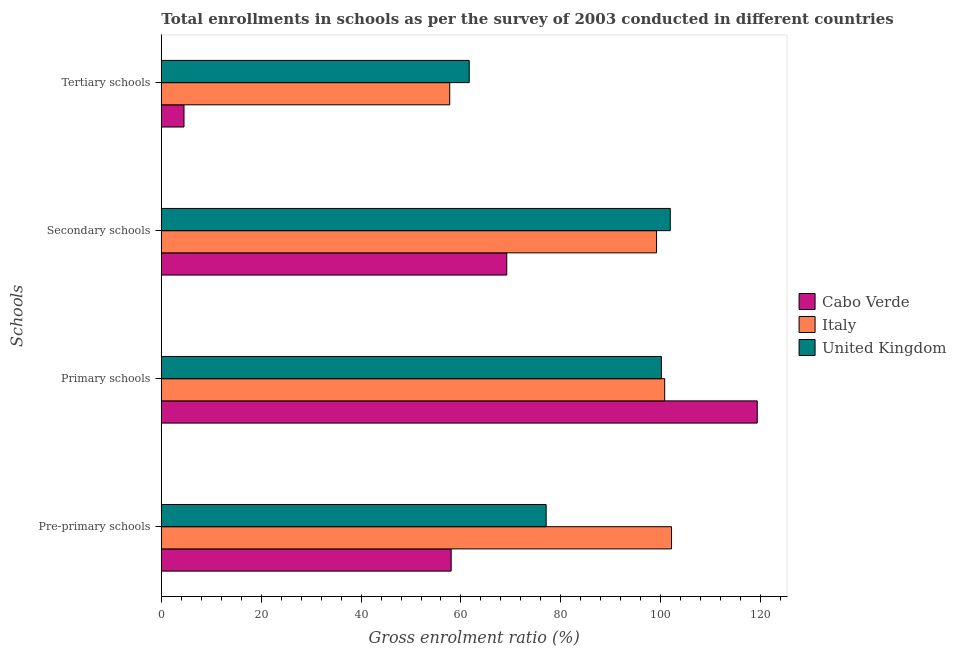Are the number of bars per tick equal to the number of legend labels?
Offer a terse response. Yes. Are the number of bars on each tick of the Y-axis equal?
Keep it short and to the point. Yes. How many bars are there on the 4th tick from the top?
Your answer should be very brief. 3. What is the label of the 2nd group of bars from the top?
Provide a succinct answer. Secondary schools. What is the gross enrolment ratio in tertiary schools in Italy?
Provide a succinct answer. 57.75. Across all countries, what is the maximum gross enrolment ratio in pre-primary schools?
Make the answer very short. 102.16. Across all countries, what is the minimum gross enrolment ratio in primary schools?
Give a very brief answer. 100.13. In which country was the gross enrolment ratio in tertiary schools minimum?
Offer a very short reply. Cabo Verde. What is the total gross enrolment ratio in pre-primary schools in the graph?
Provide a short and direct response. 237.26. What is the difference between the gross enrolment ratio in primary schools in United Kingdom and that in Cabo Verde?
Offer a very short reply. -19.2. What is the difference between the gross enrolment ratio in secondary schools in Cabo Verde and the gross enrolment ratio in tertiary schools in United Kingdom?
Your response must be concise. 7.51. What is the average gross enrolment ratio in primary schools per country?
Your response must be concise. 106.75. What is the difference between the gross enrolment ratio in tertiary schools and gross enrolment ratio in primary schools in Cabo Verde?
Provide a succinct answer. -114.79. What is the ratio of the gross enrolment ratio in primary schools in Cabo Verde to that in Italy?
Your response must be concise. 1.18. Is the gross enrolment ratio in tertiary schools in Cabo Verde less than that in United Kingdom?
Ensure brevity in your answer.  Yes. Is the difference between the gross enrolment ratio in primary schools in Italy and United Kingdom greater than the difference between the gross enrolment ratio in tertiary schools in Italy and United Kingdom?
Give a very brief answer. Yes. What is the difference between the highest and the second highest gross enrolment ratio in pre-primary schools?
Keep it short and to the point. 25.1. What is the difference between the highest and the lowest gross enrolment ratio in primary schools?
Your answer should be very brief. 19.2. In how many countries, is the gross enrolment ratio in tertiary schools greater than the average gross enrolment ratio in tertiary schools taken over all countries?
Offer a very short reply. 2. Is the sum of the gross enrolment ratio in secondary schools in Italy and United Kingdom greater than the maximum gross enrolment ratio in pre-primary schools across all countries?
Keep it short and to the point. Yes. What does the 1st bar from the bottom in Primary schools represents?
Ensure brevity in your answer.  Cabo Verde. Is it the case that in every country, the sum of the gross enrolment ratio in pre-primary schools and gross enrolment ratio in primary schools is greater than the gross enrolment ratio in secondary schools?
Keep it short and to the point. Yes. How many bars are there?
Provide a short and direct response. 12. Are all the bars in the graph horizontal?
Provide a short and direct response. Yes. How many countries are there in the graph?
Ensure brevity in your answer.  3. Does the graph contain grids?
Offer a terse response. No. Where does the legend appear in the graph?
Offer a very short reply. Center right. How many legend labels are there?
Offer a terse response. 3. How are the legend labels stacked?
Provide a short and direct response. Vertical. What is the title of the graph?
Give a very brief answer. Total enrollments in schools as per the survey of 2003 conducted in different countries. Does "Macedonia" appear as one of the legend labels in the graph?
Provide a succinct answer. No. What is the label or title of the Y-axis?
Ensure brevity in your answer.  Schools. What is the Gross enrolment ratio (%) in Cabo Verde in Pre-primary schools?
Your answer should be compact. 58.04. What is the Gross enrolment ratio (%) of Italy in Pre-primary schools?
Your response must be concise. 102.16. What is the Gross enrolment ratio (%) of United Kingdom in Pre-primary schools?
Give a very brief answer. 77.06. What is the Gross enrolment ratio (%) in Cabo Verde in Primary schools?
Keep it short and to the point. 119.33. What is the Gross enrolment ratio (%) in Italy in Primary schools?
Make the answer very short. 100.79. What is the Gross enrolment ratio (%) in United Kingdom in Primary schools?
Make the answer very short. 100.13. What is the Gross enrolment ratio (%) of Cabo Verde in Secondary schools?
Provide a succinct answer. 69.17. What is the Gross enrolment ratio (%) in Italy in Secondary schools?
Offer a very short reply. 99.16. What is the Gross enrolment ratio (%) in United Kingdom in Secondary schools?
Your response must be concise. 101.91. What is the Gross enrolment ratio (%) in Cabo Verde in Tertiary schools?
Keep it short and to the point. 4.54. What is the Gross enrolment ratio (%) in Italy in Tertiary schools?
Offer a very short reply. 57.75. What is the Gross enrolment ratio (%) in United Kingdom in Tertiary schools?
Your answer should be compact. 61.66. Across all Schools, what is the maximum Gross enrolment ratio (%) of Cabo Verde?
Make the answer very short. 119.33. Across all Schools, what is the maximum Gross enrolment ratio (%) of Italy?
Your answer should be compact. 102.16. Across all Schools, what is the maximum Gross enrolment ratio (%) of United Kingdom?
Make the answer very short. 101.91. Across all Schools, what is the minimum Gross enrolment ratio (%) in Cabo Verde?
Offer a terse response. 4.54. Across all Schools, what is the minimum Gross enrolment ratio (%) in Italy?
Make the answer very short. 57.75. Across all Schools, what is the minimum Gross enrolment ratio (%) in United Kingdom?
Offer a terse response. 61.66. What is the total Gross enrolment ratio (%) of Cabo Verde in the graph?
Your answer should be compact. 251.08. What is the total Gross enrolment ratio (%) of Italy in the graph?
Your answer should be compact. 359.87. What is the total Gross enrolment ratio (%) in United Kingdom in the graph?
Make the answer very short. 340.76. What is the difference between the Gross enrolment ratio (%) of Cabo Verde in Pre-primary schools and that in Primary schools?
Keep it short and to the point. -61.29. What is the difference between the Gross enrolment ratio (%) in Italy in Pre-primary schools and that in Primary schools?
Offer a terse response. 1.37. What is the difference between the Gross enrolment ratio (%) of United Kingdom in Pre-primary schools and that in Primary schools?
Your answer should be very brief. -23.07. What is the difference between the Gross enrolment ratio (%) in Cabo Verde in Pre-primary schools and that in Secondary schools?
Keep it short and to the point. -11.13. What is the difference between the Gross enrolment ratio (%) of Italy in Pre-primary schools and that in Secondary schools?
Make the answer very short. 3. What is the difference between the Gross enrolment ratio (%) in United Kingdom in Pre-primary schools and that in Secondary schools?
Keep it short and to the point. -24.85. What is the difference between the Gross enrolment ratio (%) in Cabo Verde in Pre-primary schools and that in Tertiary schools?
Ensure brevity in your answer.  53.5. What is the difference between the Gross enrolment ratio (%) of Italy in Pre-primary schools and that in Tertiary schools?
Offer a terse response. 44.41. What is the difference between the Gross enrolment ratio (%) of United Kingdom in Pre-primary schools and that in Tertiary schools?
Ensure brevity in your answer.  15.4. What is the difference between the Gross enrolment ratio (%) of Cabo Verde in Primary schools and that in Secondary schools?
Provide a succinct answer. 50.16. What is the difference between the Gross enrolment ratio (%) of Italy in Primary schools and that in Secondary schools?
Your response must be concise. 1.63. What is the difference between the Gross enrolment ratio (%) in United Kingdom in Primary schools and that in Secondary schools?
Ensure brevity in your answer.  -1.78. What is the difference between the Gross enrolment ratio (%) in Cabo Verde in Primary schools and that in Tertiary schools?
Provide a succinct answer. 114.79. What is the difference between the Gross enrolment ratio (%) in Italy in Primary schools and that in Tertiary schools?
Ensure brevity in your answer.  43.04. What is the difference between the Gross enrolment ratio (%) in United Kingdom in Primary schools and that in Tertiary schools?
Offer a terse response. 38.48. What is the difference between the Gross enrolment ratio (%) of Cabo Verde in Secondary schools and that in Tertiary schools?
Provide a succinct answer. 64.63. What is the difference between the Gross enrolment ratio (%) in Italy in Secondary schools and that in Tertiary schools?
Your answer should be very brief. 41.41. What is the difference between the Gross enrolment ratio (%) in United Kingdom in Secondary schools and that in Tertiary schools?
Provide a succinct answer. 40.25. What is the difference between the Gross enrolment ratio (%) in Cabo Verde in Pre-primary schools and the Gross enrolment ratio (%) in Italy in Primary schools?
Ensure brevity in your answer.  -42.75. What is the difference between the Gross enrolment ratio (%) of Cabo Verde in Pre-primary schools and the Gross enrolment ratio (%) of United Kingdom in Primary schools?
Provide a short and direct response. -42.09. What is the difference between the Gross enrolment ratio (%) of Italy in Pre-primary schools and the Gross enrolment ratio (%) of United Kingdom in Primary schools?
Make the answer very short. 2.03. What is the difference between the Gross enrolment ratio (%) of Cabo Verde in Pre-primary schools and the Gross enrolment ratio (%) of Italy in Secondary schools?
Keep it short and to the point. -41.13. What is the difference between the Gross enrolment ratio (%) in Cabo Verde in Pre-primary schools and the Gross enrolment ratio (%) in United Kingdom in Secondary schools?
Give a very brief answer. -43.87. What is the difference between the Gross enrolment ratio (%) of Italy in Pre-primary schools and the Gross enrolment ratio (%) of United Kingdom in Secondary schools?
Your answer should be compact. 0.25. What is the difference between the Gross enrolment ratio (%) of Cabo Verde in Pre-primary schools and the Gross enrolment ratio (%) of Italy in Tertiary schools?
Your response must be concise. 0.29. What is the difference between the Gross enrolment ratio (%) in Cabo Verde in Pre-primary schools and the Gross enrolment ratio (%) in United Kingdom in Tertiary schools?
Provide a short and direct response. -3.62. What is the difference between the Gross enrolment ratio (%) in Italy in Pre-primary schools and the Gross enrolment ratio (%) in United Kingdom in Tertiary schools?
Give a very brief answer. 40.51. What is the difference between the Gross enrolment ratio (%) in Cabo Verde in Primary schools and the Gross enrolment ratio (%) in Italy in Secondary schools?
Provide a succinct answer. 20.17. What is the difference between the Gross enrolment ratio (%) in Cabo Verde in Primary schools and the Gross enrolment ratio (%) in United Kingdom in Secondary schools?
Make the answer very short. 17.42. What is the difference between the Gross enrolment ratio (%) in Italy in Primary schools and the Gross enrolment ratio (%) in United Kingdom in Secondary schools?
Offer a very short reply. -1.12. What is the difference between the Gross enrolment ratio (%) in Cabo Verde in Primary schools and the Gross enrolment ratio (%) in Italy in Tertiary schools?
Offer a terse response. 61.58. What is the difference between the Gross enrolment ratio (%) of Cabo Verde in Primary schools and the Gross enrolment ratio (%) of United Kingdom in Tertiary schools?
Give a very brief answer. 57.67. What is the difference between the Gross enrolment ratio (%) of Italy in Primary schools and the Gross enrolment ratio (%) of United Kingdom in Tertiary schools?
Offer a very short reply. 39.14. What is the difference between the Gross enrolment ratio (%) of Cabo Verde in Secondary schools and the Gross enrolment ratio (%) of Italy in Tertiary schools?
Your answer should be very brief. 11.42. What is the difference between the Gross enrolment ratio (%) in Cabo Verde in Secondary schools and the Gross enrolment ratio (%) in United Kingdom in Tertiary schools?
Offer a terse response. 7.51. What is the difference between the Gross enrolment ratio (%) in Italy in Secondary schools and the Gross enrolment ratio (%) in United Kingdom in Tertiary schools?
Ensure brevity in your answer.  37.51. What is the average Gross enrolment ratio (%) of Cabo Verde per Schools?
Give a very brief answer. 62.77. What is the average Gross enrolment ratio (%) in Italy per Schools?
Your answer should be very brief. 89.97. What is the average Gross enrolment ratio (%) in United Kingdom per Schools?
Provide a succinct answer. 85.19. What is the difference between the Gross enrolment ratio (%) of Cabo Verde and Gross enrolment ratio (%) of Italy in Pre-primary schools?
Provide a succinct answer. -44.12. What is the difference between the Gross enrolment ratio (%) of Cabo Verde and Gross enrolment ratio (%) of United Kingdom in Pre-primary schools?
Provide a succinct answer. -19.02. What is the difference between the Gross enrolment ratio (%) of Italy and Gross enrolment ratio (%) of United Kingdom in Pre-primary schools?
Provide a succinct answer. 25.1. What is the difference between the Gross enrolment ratio (%) in Cabo Verde and Gross enrolment ratio (%) in Italy in Primary schools?
Keep it short and to the point. 18.54. What is the difference between the Gross enrolment ratio (%) of Cabo Verde and Gross enrolment ratio (%) of United Kingdom in Primary schools?
Keep it short and to the point. 19.2. What is the difference between the Gross enrolment ratio (%) of Italy and Gross enrolment ratio (%) of United Kingdom in Primary schools?
Your answer should be compact. 0.66. What is the difference between the Gross enrolment ratio (%) in Cabo Verde and Gross enrolment ratio (%) in Italy in Secondary schools?
Provide a short and direct response. -30. What is the difference between the Gross enrolment ratio (%) of Cabo Verde and Gross enrolment ratio (%) of United Kingdom in Secondary schools?
Provide a succinct answer. -32.74. What is the difference between the Gross enrolment ratio (%) in Italy and Gross enrolment ratio (%) in United Kingdom in Secondary schools?
Your response must be concise. -2.75. What is the difference between the Gross enrolment ratio (%) of Cabo Verde and Gross enrolment ratio (%) of Italy in Tertiary schools?
Provide a succinct answer. -53.21. What is the difference between the Gross enrolment ratio (%) of Cabo Verde and Gross enrolment ratio (%) of United Kingdom in Tertiary schools?
Your answer should be compact. -57.12. What is the difference between the Gross enrolment ratio (%) in Italy and Gross enrolment ratio (%) in United Kingdom in Tertiary schools?
Keep it short and to the point. -3.91. What is the ratio of the Gross enrolment ratio (%) of Cabo Verde in Pre-primary schools to that in Primary schools?
Offer a terse response. 0.49. What is the ratio of the Gross enrolment ratio (%) of Italy in Pre-primary schools to that in Primary schools?
Your answer should be compact. 1.01. What is the ratio of the Gross enrolment ratio (%) in United Kingdom in Pre-primary schools to that in Primary schools?
Offer a terse response. 0.77. What is the ratio of the Gross enrolment ratio (%) of Cabo Verde in Pre-primary schools to that in Secondary schools?
Make the answer very short. 0.84. What is the ratio of the Gross enrolment ratio (%) of Italy in Pre-primary schools to that in Secondary schools?
Provide a succinct answer. 1.03. What is the ratio of the Gross enrolment ratio (%) in United Kingdom in Pre-primary schools to that in Secondary schools?
Your answer should be very brief. 0.76. What is the ratio of the Gross enrolment ratio (%) in Cabo Verde in Pre-primary schools to that in Tertiary schools?
Ensure brevity in your answer.  12.78. What is the ratio of the Gross enrolment ratio (%) of Italy in Pre-primary schools to that in Tertiary schools?
Your answer should be very brief. 1.77. What is the ratio of the Gross enrolment ratio (%) in United Kingdom in Pre-primary schools to that in Tertiary schools?
Ensure brevity in your answer.  1.25. What is the ratio of the Gross enrolment ratio (%) in Cabo Verde in Primary schools to that in Secondary schools?
Give a very brief answer. 1.73. What is the ratio of the Gross enrolment ratio (%) of Italy in Primary schools to that in Secondary schools?
Keep it short and to the point. 1.02. What is the ratio of the Gross enrolment ratio (%) of United Kingdom in Primary schools to that in Secondary schools?
Offer a very short reply. 0.98. What is the ratio of the Gross enrolment ratio (%) in Cabo Verde in Primary schools to that in Tertiary schools?
Keep it short and to the point. 26.27. What is the ratio of the Gross enrolment ratio (%) in Italy in Primary schools to that in Tertiary schools?
Offer a terse response. 1.75. What is the ratio of the Gross enrolment ratio (%) in United Kingdom in Primary schools to that in Tertiary schools?
Keep it short and to the point. 1.62. What is the ratio of the Gross enrolment ratio (%) of Cabo Verde in Secondary schools to that in Tertiary schools?
Your response must be concise. 15.23. What is the ratio of the Gross enrolment ratio (%) in Italy in Secondary schools to that in Tertiary schools?
Your answer should be compact. 1.72. What is the ratio of the Gross enrolment ratio (%) in United Kingdom in Secondary schools to that in Tertiary schools?
Offer a very short reply. 1.65. What is the difference between the highest and the second highest Gross enrolment ratio (%) in Cabo Verde?
Your answer should be compact. 50.16. What is the difference between the highest and the second highest Gross enrolment ratio (%) of Italy?
Offer a very short reply. 1.37. What is the difference between the highest and the second highest Gross enrolment ratio (%) in United Kingdom?
Give a very brief answer. 1.78. What is the difference between the highest and the lowest Gross enrolment ratio (%) in Cabo Verde?
Ensure brevity in your answer.  114.79. What is the difference between the highest and the lowest Gross enrolment ratio (%) in Italy?
Your answer should be compact. 44.41. What is the difference between the highest and the lowest Gross enrolment ratio (%) of United Kingdom?
Provide a succinct answer. 40.25. 